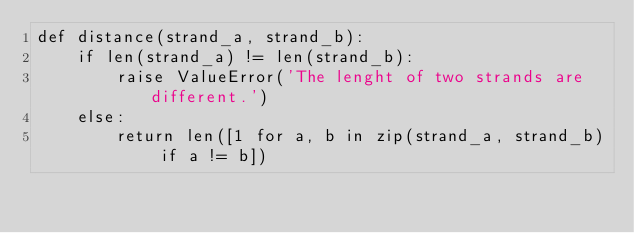<code> <loc_0><loc_0><loc_500><loc_500><_Python_>def distance(strand_a, strand_b):
    if len(strand_a) != len(strand_b):
        raise ValueError('The lenght of two strands are different.')
    else:
        return len([1 for a, b in zip(strand_a, strand_b) if a != b])</code> 